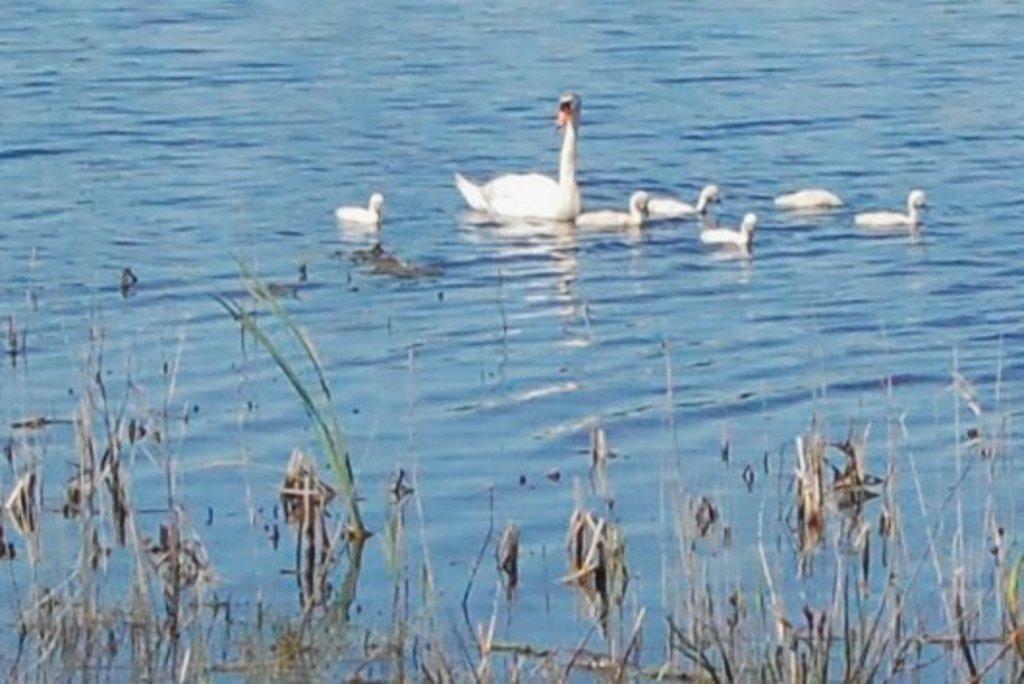Could you give a brief overview of what you see in this image? In this picture I can see a duck and few ducklings in the water and I can see few water plants. 